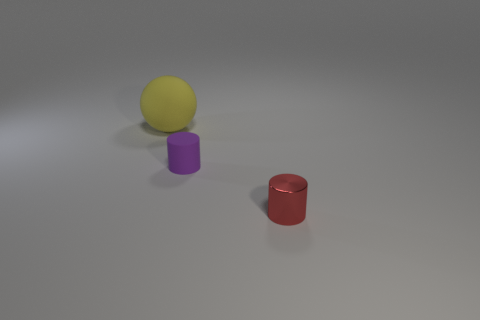The other tiny rubber object that is the same shape as the tiny red object is what color?
Give a very brief answer. Purple. Are there the same number of tiny metal cylinders that are behind the small purple cylinder and yellow spheres?
Provide a succinct answer. No. How many cubes are tiny red things or large objects?
Give a very brief answer. 0. The cylinder that is made of the same material as the sphere is what color?
Keep it short and to the point. Purple. Is the material of the purple thing the same as the thing right of the tiny purple matte object?
Your response must be concise. No. What number of objects are either big matte things or small purple objects?
Provide a succinct answer. 2. Is there a purple object that has the same shape as the tiny red shiny thing?
Provide a succinct answer. Yes. There is a red cylinder; how many cylinders are in front of it?
Your answer should be compact. 0. There is a thing in front of the rubber thing in front of the large yellow matte sphere; what is it made of?
Offer a terse response. Metal. There is a red thing that is the same size as the purple matte thing; what is its material?
Your answer should be very brief. Metal. 